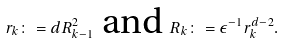<formula> <loc_0><loc_0><loc_500><loc_500>r _ { k } \colon = d R _ { k - 1 } ^ { 2 } \text { and } R _ { k } \colon = \epsilon ^ { - 1 } r _ { k } ^ { d - 2 } .</formula> 